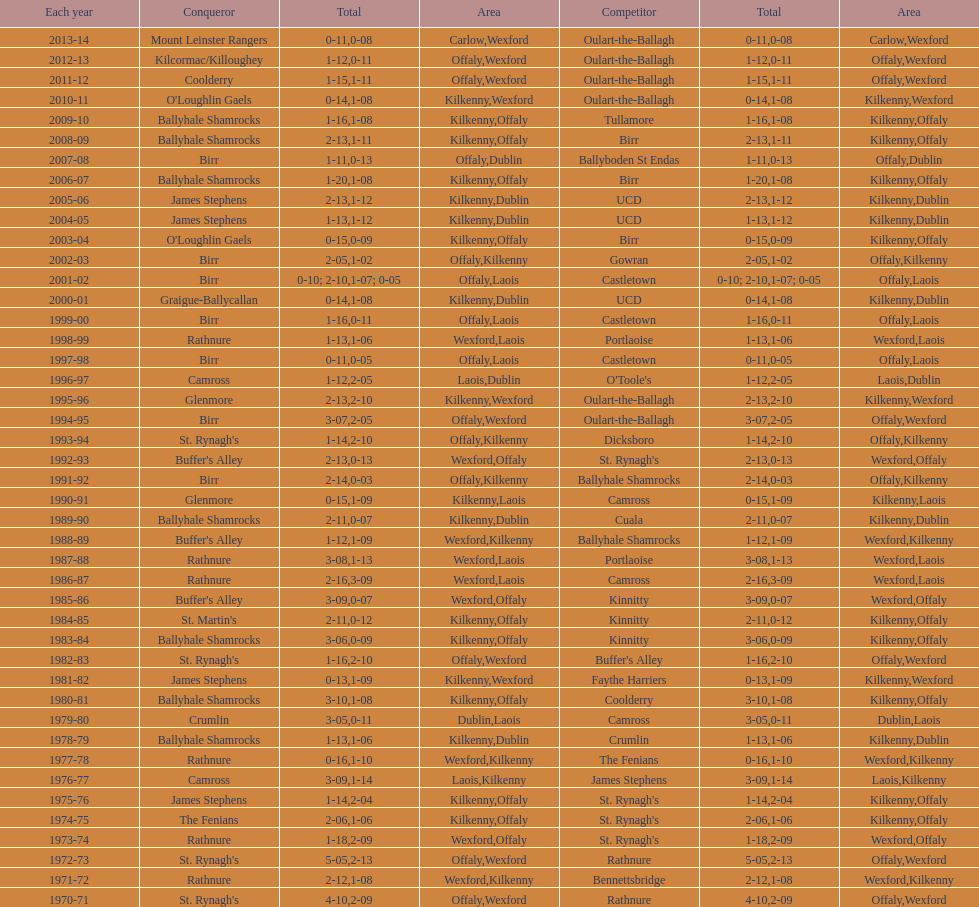What was the last season the leinster senior club hurling championships was won by a score differential of less than 11? 2007-08. 